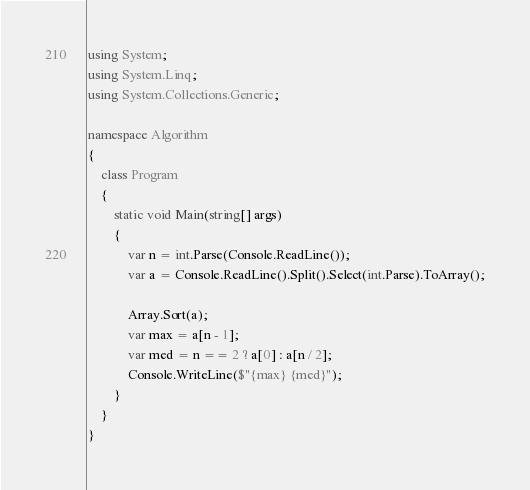<code> <loc_0><loc_0><loc_500><loc_500><_C#_>using System;
using System.Linq;
using System.Collections.Generic;

namespace Algorithm
{
    class Program
    {
        static void Main(string[] args)
        {
            var n = int.Parse(Console.ReadLine());
            var a = Console.ReadLine().Split().Select(int.Parse).ToArray();

            Array.Sort(a);
            var max = a[n - 1];
            var med = n == 2 ? a[0] : a[n / 2];
            Console.WriteLine($"{max} {med}");
        }
    }
}
</code> 